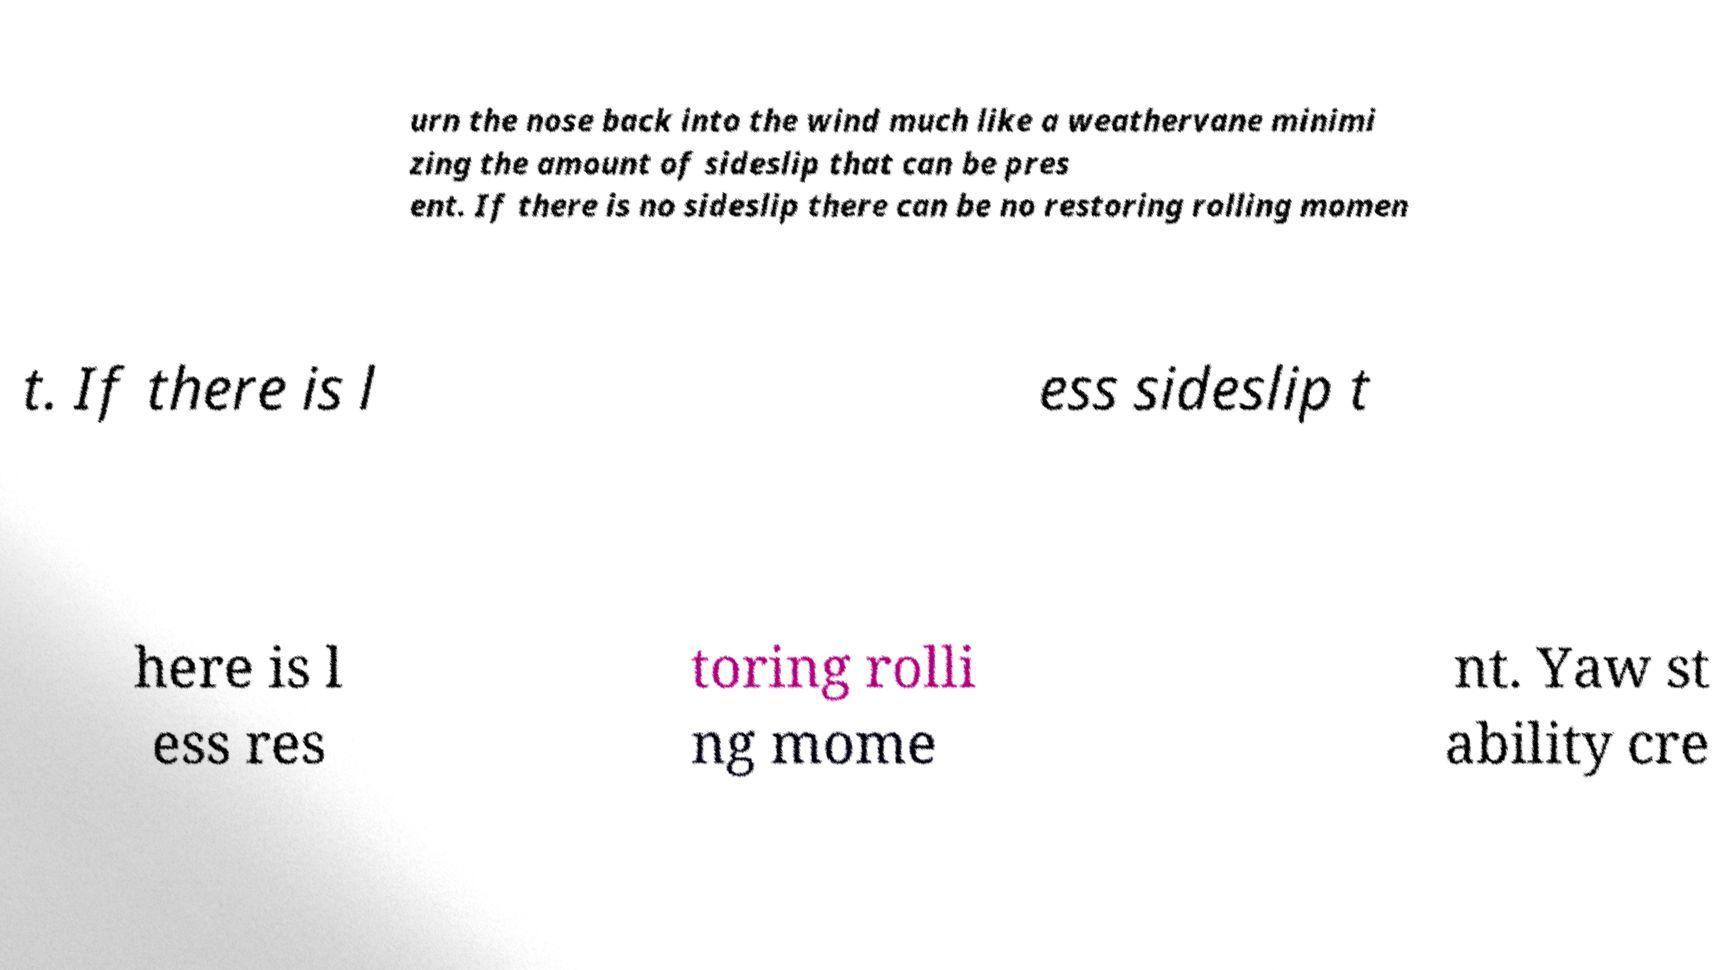Please read and relay the text visible in this image. What does it say? urn the nose back into the wind much like a weathervane minimi zing the amount of sideslip that can be pres ent. If there is no sideslip there can be no restoring rolling momen t. If there is l ess sideslip t here is l ess res toring rolli ng mome nt. Yaw st ability cre 